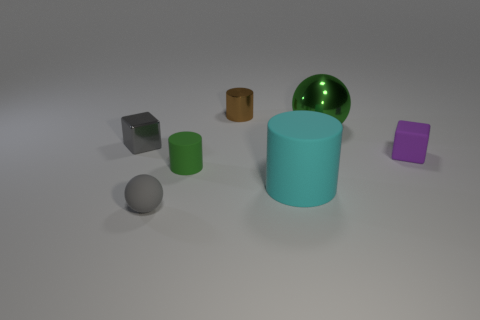Do the small green matte object and the object right of the green shiny ball have the same shape?
Your answer should be compact. No. How many blocks are to the left of the big cylinder?
Give a very brief answer. 1. There is a tiny thing that is to the right of the large sphere; is it the same shape as the tiny gray metallic thing?
Offer a very short reply. Yes. There is a big object that is in front of the green metal ball; what color is it?
Give a very brief answer. Cyan. There is a small purple thing that is the same material as the large cyan cylinder; what is its shape?
Your answer should be compact. Cube. Is there anything else that has the same color as the large cylinder?
Ensure brevity in your answer.  No. Are there more small things to the right of the gray ball than cylinders that are right of the cyan cylinder?
Provide a short and direct response. Yes. What number of gray matte spheres have the same size as the green cylinder?
Your response must be concise. 1. Are there fewer matte cubes that are in front of the big cyan rubber cylinder than green rubber things that are left of the metallic sphere?
Offer a very short reply. Yes. Are there any brown metal things of the same shape as the tiny purple thing?
Provide a succinct answer. No. 